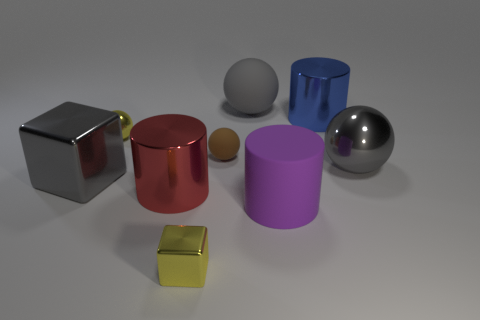Can you tell me the colors of the objects in the image? Certainly! From left to right, there's a chrome cube, a red cylinder, a small brown sphere, a large gray sphere next to a purple cylinder, a blue cylinder, and a small gold cube. The background is a neutral gray, which complements the objects’ colors. 